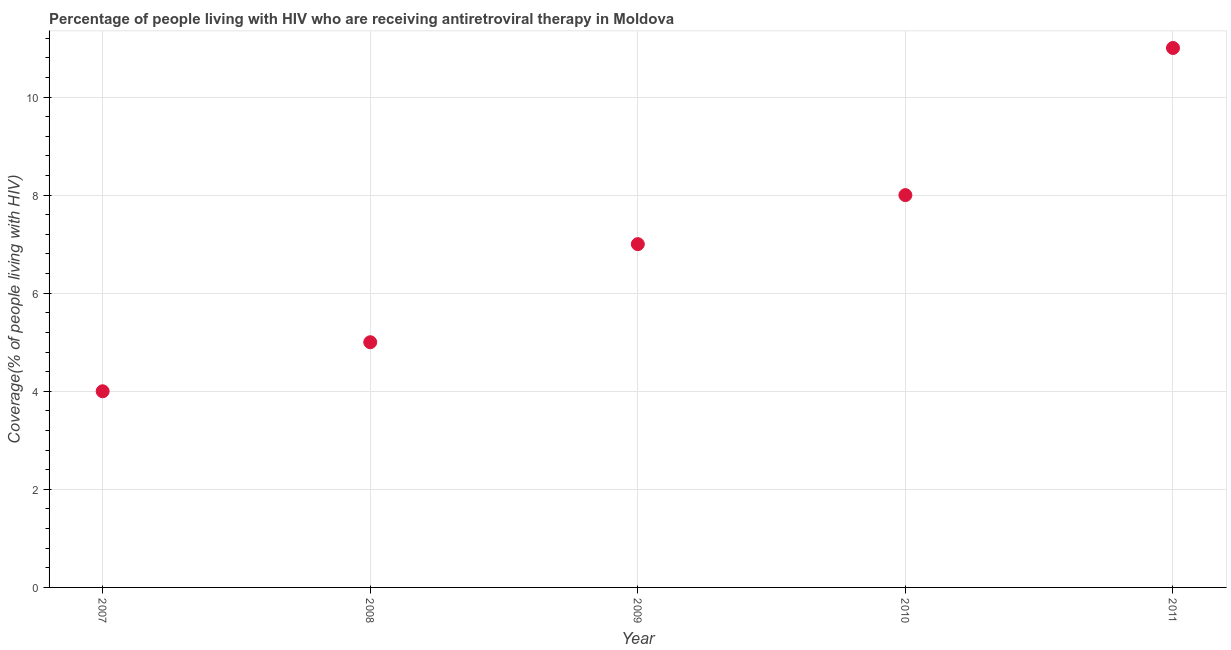What is the antiretroviral therapy coverage in 2010?
Keep it short and to the point. 8. Across all years, what is the maximum antiretroviral therapy coverage?
Your answer should be compact. 11. Across all years, what is the minimum antiretroviral therapy coverage?
Provide a succinct answer. 4. In which year was the antiretroviral therapy coverage maximum?
Your answer should be very brief. 2011. What is the sum of the antiretroviral therapy coverage?
Your answer should be compact. 35. What is the difference between the antiretroviral therapy coverage in 2010 and 2011?
Your response must be concise. -3. What is the average antiretroviral therapy coverage per year?
Your answer should be very brief. 7. What is the median antiretroviral therapy coverage?
Your answer should be very brief. 7. What is the ratio of the antiretroviral therapy coverage in 2010 to that in 2011?
Provide a short and direct response. 0.73. Is the antiretroviral therapy coverage in 2009 less than that in 2011?
Offer a terse response. Yes. Is the difference between the antiretroviral therapy coverage in 2009 and 2011 greater than the difference between any two years?
Provide a short and direct response. No. What is the difference between the highest and the second highest antiretroviral therapy coverage?
Keep it short and to the point. 3. What is the difference between the highest and the lowest antiretroviral therapy coverage?
Your response must be concise. 7. In how many years, is the antiretroviral therapy coverage greater than the average antiretroviral therapy coverage taken over all years?
Keep it short and to the point. 2. How many dotlines are there?
Offer a terse response. 1. Are the values on the major ticks of Y-axis written in scientific E-notation?
Your answer should be compact. No. Does the graph contain grids?
Your answer should be compact. Yes. What is the title of the graph?
Give a very brief answer. Percentage of people living with HIV who are receiving antiretroviral therapy in Moldova. What is the label or title of the Y-axis?
Your response must be concise. Coverage(% of people living with HIV). What is the Coverage(% of people living with HIV) in 2007?
Keep it short and to the point. 4. What is the Coverage(% of people living with HIV) in 2008?
Make the answer very short. 5. What is the Coverage(% of people living with HIV) in 2009?
Keep it short and to the point. 7. What is the difference between the Coverage(% of people living with HIV) in 2007 and 2010?
Offer a terse response. -4. What is the difference between the Coverage(% of people living with HIV) in 2007 and 2011?
Your answer should be compact. -7. What is the difference between the Coverage(% of people living with HIV) in 2008 and 2010?
Your answer should be compact. -3. What is the difference between the Coverage(% of people living with HIV) in 2008 and 2011?
Your answer should be compact. -6. What is the difference between the Coverage(% of people living with HIV) in 2009 and 2011?
Offer a very short reply. -4. What is the ratio of the Coverage(% of people living with HIV) in 2007 to that in 2009?
Provide a succinct answer. 0.57. What is the ratio of the Coverage(% of people living with HIV) in 2007 to that in 2010?
Keep it short and to the point. 0.5. What is the ratio of the Coverage(% of people living with HIV) in 2007 to that in 2011?
Provide a short and direct response. 0.36. What is the ratio of the Coverage(% of people living with HIV) in 2008 to that in 2009?
Make the answer very short. 0.71. What is the ratio of the Coverage(% of people living with HIV) in 2008 to that in 2011?
Provide a short and direct response. 0.46. What is the ratio of the Coverage(% of people living with HIV) in 2009 to that in 2011?
Provide a short and direct response. 0.64. What is the ratio of the Coverage(% of people living with HIV) in 2010 to that in 2011?
Give a very brief answer. 0.73. 